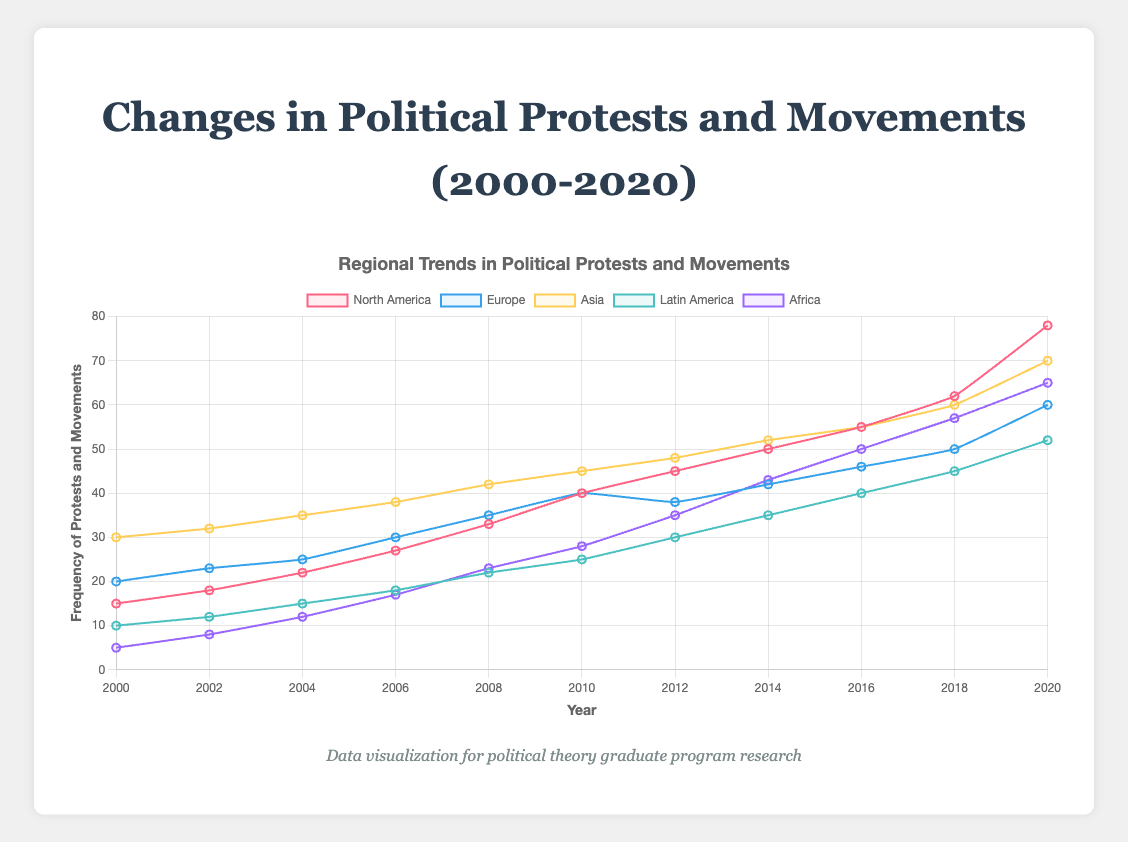Which region had the highest frequency of political protests in 2020? To answer this, observe the highest point on the graph for the year 2020. The highest frequency is attributed to North America with a frequency of 78.
Answer: North America Which region showed the most significant increase in the frequency of protests from 2016 to 2020? Calculate the difference in frequencies from 2016 to 2020 for each region: North America (78-55=23), Europe (60-46=14), Asia (70-55=15), Latin America (52-40=12), Africa (65-50=15). North America shows the largest increase of 23.
Answer: North America What was the average frequency of political protests in Africa from 2014 to 2020? List the frequencies for Africa from 2014 to 2020: 43, 50, 57, 65. Calculate the average: (43 + 50 + 57 + 65) / 4 = 215 / 4 = 53.75.
Answer: 53.75 In which year did North America and Europe have the same frequency of protests? Compare the frequencies of North America and Europe for each year. Both regions have a frequency of 40 in the year 2010.
Answer: 2010 Which region had the lowest frequency of political protests in 2008? Look at the frequencies for each region in 2008: North America (33), Europe (35), Asia (42), Latin America (22), Africa (23). Latin America had the lowest frequency number with 22.
Answer: Latin America Compare the increase in frequency of political protests in Asia and Latin America from 2000 to 2020. Which region had a greater increase? Calculate the difference between 2020 and 2000 for both regions: Asia (70-30=40) and Latin America (52-10=42). Latin America had a larger increase (42 compared to 40).
Answer: Latin America Between 2012 and 2016, which region had the highest average annual increase in the frequency of protests? Calculate the annual increase for each region: North America ((55-45)/4)=2.5, Europe ((46-38)/4)=2, Asia ((55-48)/4)=1.75, Latin America ((40-30)/4)=2.5, Africa ((50-35)/4)=3.75. Africa had the highest average annual increase of 3.75.
Answer: Africa Which region had the steadiest increase in frequency of protests during the entire period from 2000 to 2020? Assess the consistency of the increase by considering the regions: North America has ups and downs, Europe shows a steady increase except a small dip, Asia maintains a more steady increase with no dips, Latin America shows a slower but consistent increase, Africa has fluctuations. Asia shows the steadiest increase overall.
Answer: Asia How did the frequency of protests in Europe change during the economic crisis period from 2008 to 2012? Look at the frequencies in Europe from 2008 (35), 2010 (40), and 2012 (38). The frequency increased from 35 to 40 in 2010 but slightly decreased to 38 by 2012.
Answer: Slight increase then a slight decrease By how much did the frequency of protests in Africa increase from 2000 to 2008? Observe the data points for Africa in 2000 (5) and 2008 (23). Subtract the frequency in 2000 from the frequency in 2008: (23-5)=18. The increase is by 18.
Answer: 18 